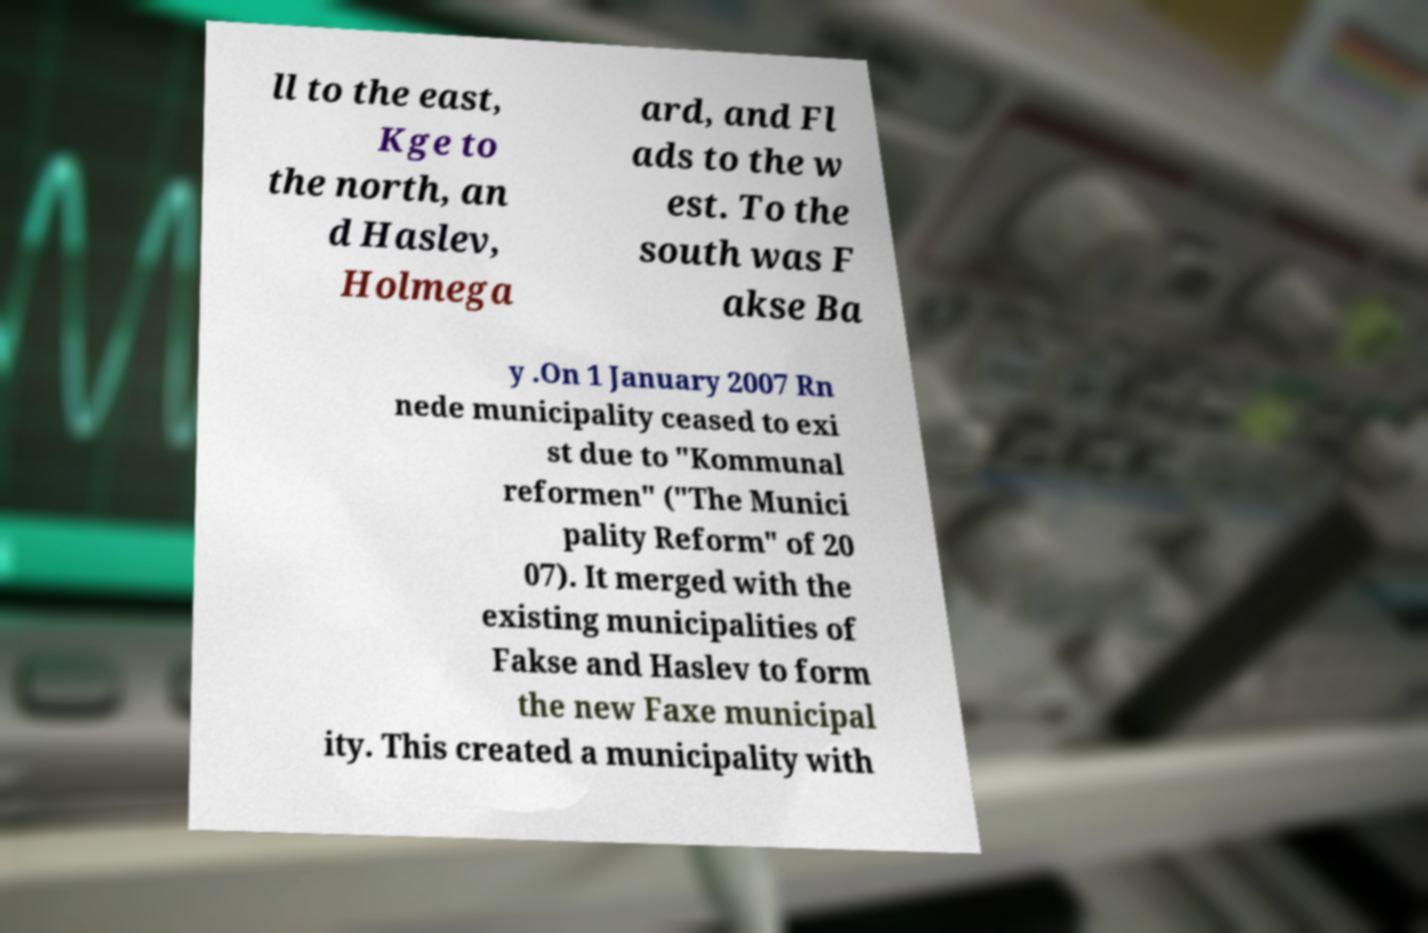For documentation purposes, I need the text within this image transcribed. Could you provide that? ll to the east, Kge to the north, an d Haslev, Holmega ard, and Fl ads to the w est. To the south was F akse Ba y .On 1 January 2007 Rn nede municipality ceased to exi st due to "Kommunal reformen" ("The Munici pality Reform" of 20 07). It merged with the existing municipalities of Fakse and Haslev to form the new Faxe municipal ity. This created a municipality with 